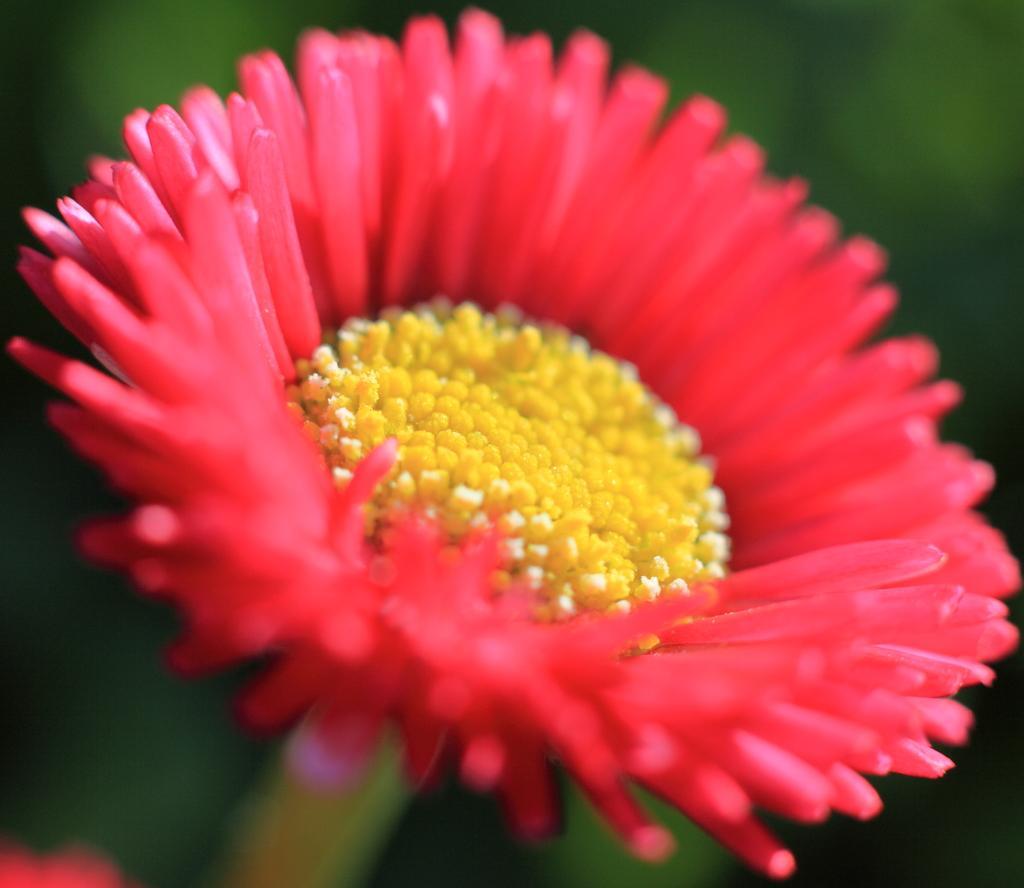Can you describe this image briefly? In this picture we can see the flower. 